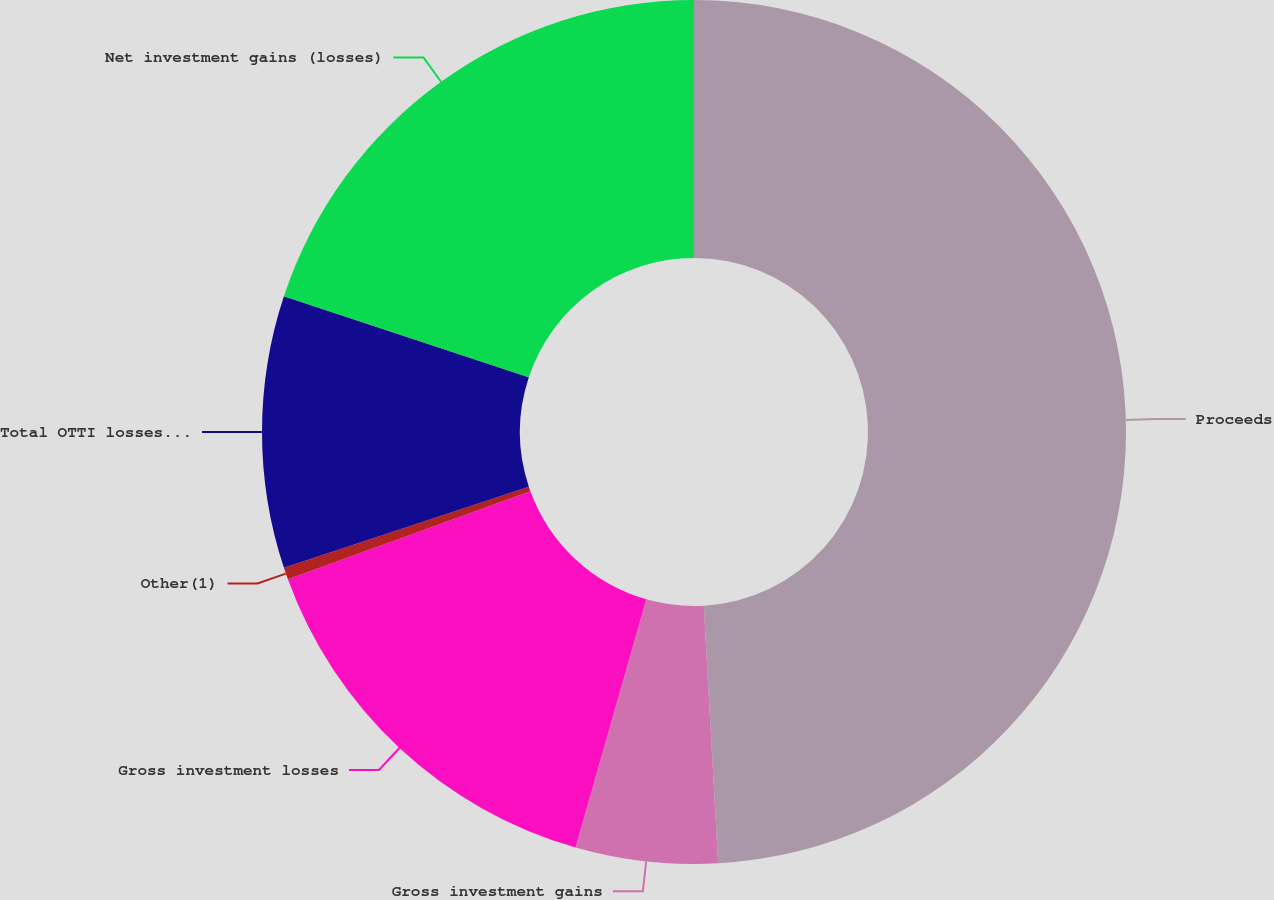<chart> <loc_0><loc_0><loc_500><loc_500><pie_chart><fcel>Proceeds<fcel>Gross investment gains<fcel>Gross investment losses<fcel>Other(1)<fcel>Total OTTI losses recognized<fcel>Net investment gains (losses)<nl><fcel>49.11%<fcel>5.31%<fcel>15.04%<fcel>0.45%<fcel>10.18%<fcel>19.91%<nl></chart> 